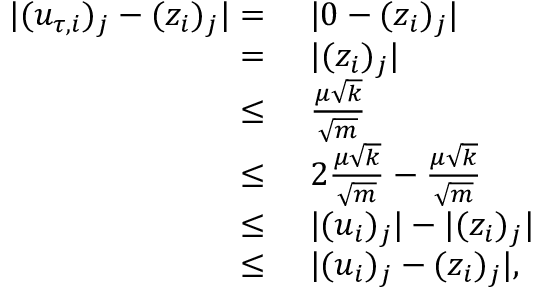<formula> <loc_0><loc_0><loc_500><loc_500>\begin{array} { r l } { | ( u _ { \tau , i } ) _ { j } - ( z _ { i } ) _ { j } | = } & { | 0 - ( z _ { i } ) _ { j } | } \\ { = } & { | ( z _ { i } ) _ { j } | } \\ { \leq } & { \frac { \mu \sqrt { k } } { \sqrt { m } } } \\ { \leq } & { 2 \frac { \mu \sqrt { k } } { \sqrt { m } } - \frac { \mu \sqrt { k } } { \sqrt { m } } } \\ { \leq } & { | ( u _ { i } ) _ { j } | - | ( z _ { i } ) _ { j } | } \\ { \leq } & { | ( u _ { i } ) _ { j } - ( z _ { i } ) _ { j } | , } \end{array}</formula> 